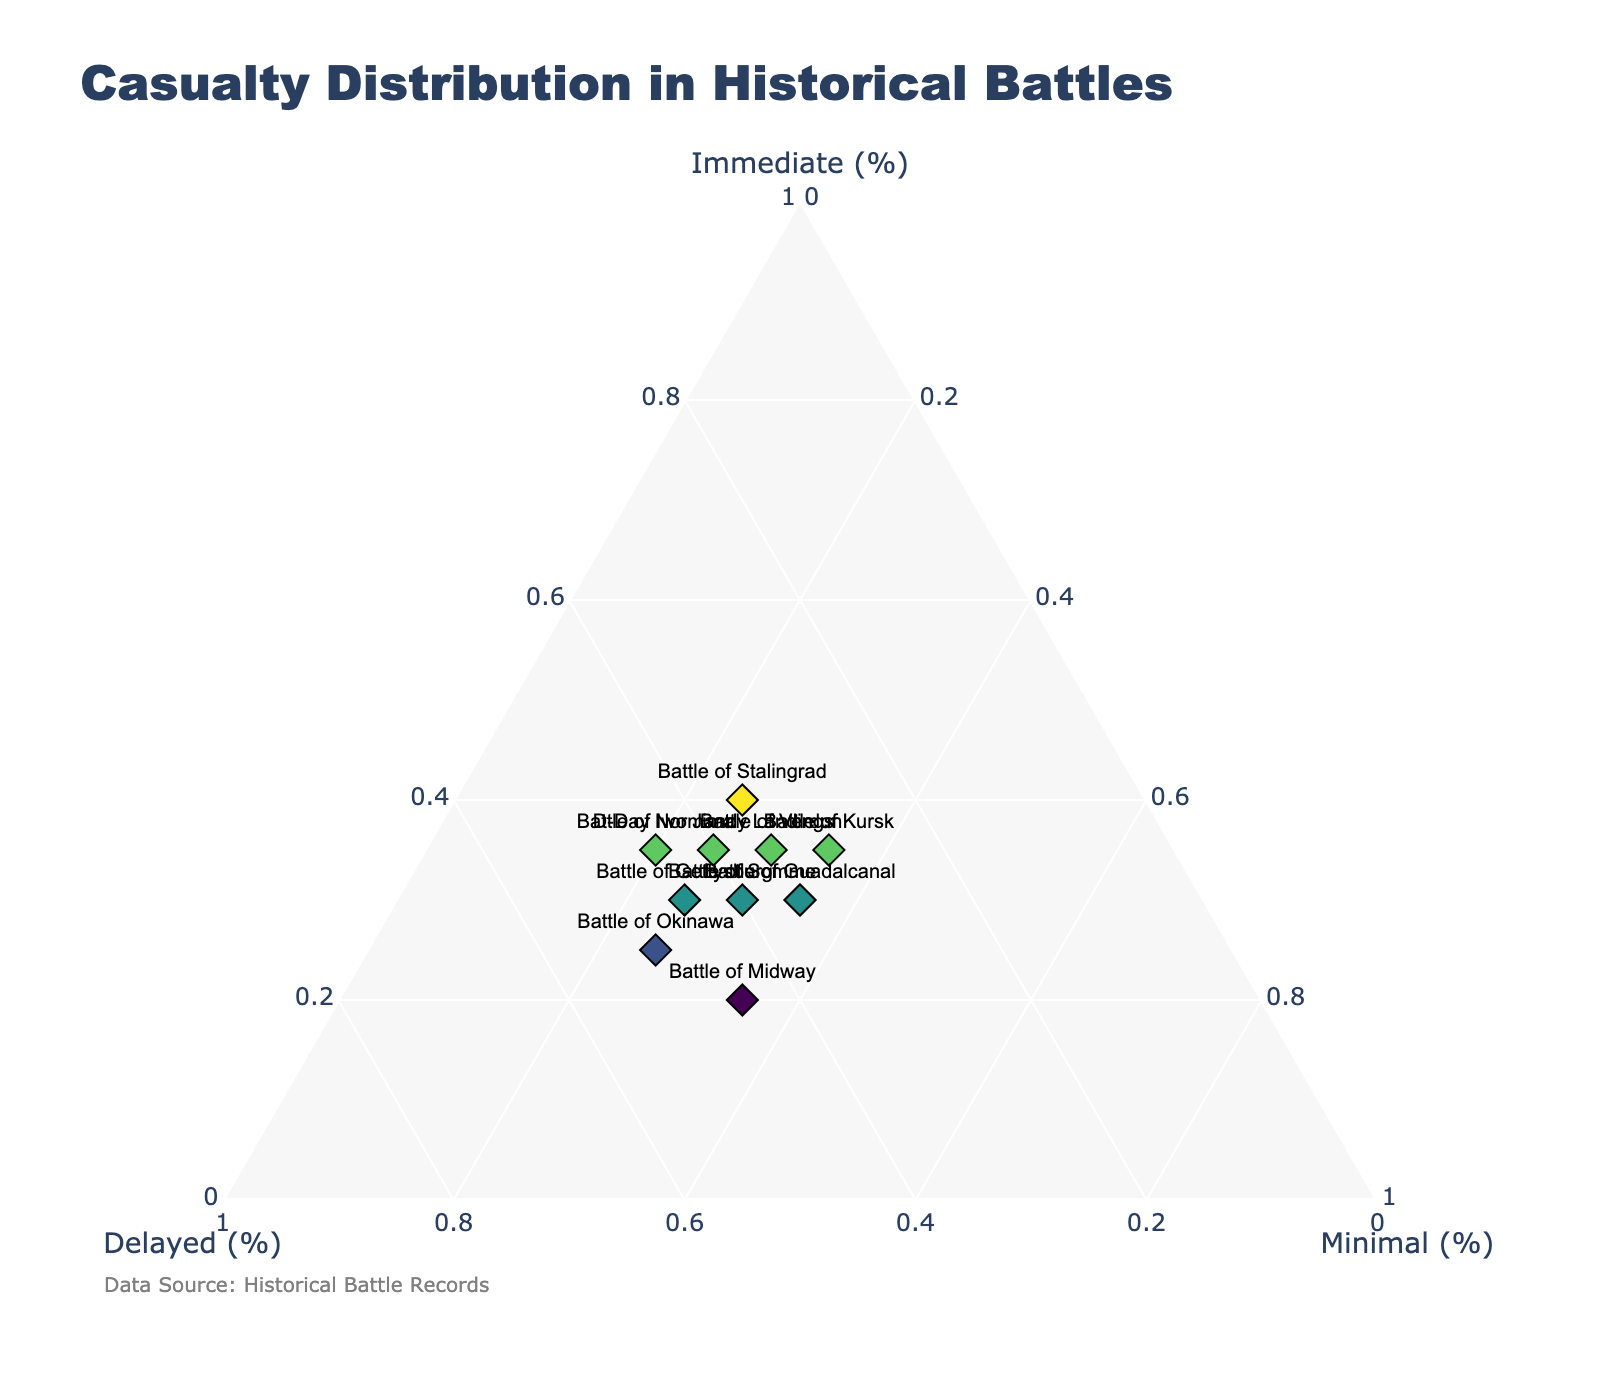What is the title of the figure? The title is displayed at the top of the plot and reads "Casualty Distribution in Historical Battles".
Answer: Casualty Distribution in Historical Battles Which battle had the most 'Immediate' casualties? By examining the data points on the ternary plot, the Battle of Stalingrad is positioned closest to the 'Immediate' axis, indicating it has the highest percentage of 'Immediate' casualties.
Answer: Battle of Stalingrad For which battle are the 'Immediate' and 'Delayed' casualty percentages equal? The ternary plot shows that the Battle of Verdun has both 'Immediate' and 'Delayed' percentages balanced at 35%.
Answer: Battle of Verdun Which battle had the least 'Minimal' casualties? The battle with the data point furthest from the 'Minimal' axis is Battle of Iwo Jima, which indicates it has the lowest 'Minimal' casualties with a percentage of 20%.
Answer: Battle of Iwo Jima How many battles have 25% 'Minimal' casualties? By counting the data points aligned with the 'Minimal' 25% axis, we find that the Battle of Gettysburg, D-Day Normandy Landings, Battle of Stalingrad, and Battle of Okinawa all meet this criterion.
Answer: 4 Did any battle have an equal percentage of 'Immediate' and 'Minimal' casualties? The ternary plot reveals that no data point has 'Immediate' and 'Minimal' percentages at the same value, hence no battle meets this condition.
Answer: No Which battles have higher 'Delayed' casualties than 'Immediate' casualties? Observing the ternary plot for data points closer to the 'Delayed' axis than the 'Immediate' axis shows that the Battle of Gettysburg, D-Day Normandy Landings, Battle of Okinawa, Battle of Iwo Jima, and Battle of Midway fall under this category.
Answer: Battle of Gettysburg, D-Day Normandy Landings, Battle of Okinawa, Battle of Iwo Jima, Battle of Midway What is the average percentage of 'Minimal' casualties across all battles? Adding 'Minimal' percentages for all battles (25+25+25+25+30+30+20+35+35+35=285) and dividing by the number of battles (10), we get an average of 28.5%.
Answer: 28.5% Which battle has the highest combined percentage of 'Immediate' and 'Minimal' casualties? Summing the 'Immediate' and 'Minimal' values for each battle and identifying the highest total shows the Battle of Kursk with 70% (35 'Immediate' + 35 'Minimal').
Answer: Battle of Kursk 